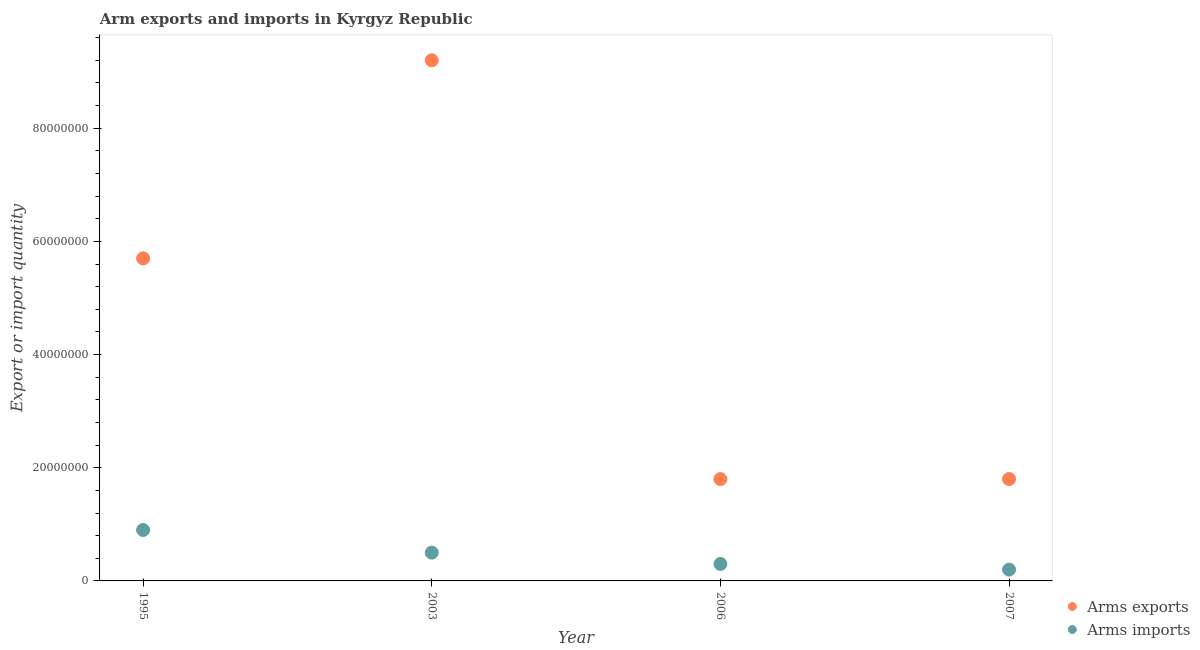How many different coloured dotlines are there?
Your answer should be very brief. 2. What is the arms imports in 2003?
Your answer should be very brief. 5.00e+06. Across all years, what is the maximum arms exports?
Give a very brief answer. 9.20e+07. Across all years, what is the minimum arms exports?
Keep it short and to the point. 1.80e+07. In which year was the arms imports maximum?
Give a very brief answer. 1995. In which year was the arms imports minimum?
Give a very brief answer. 2007. What is the total arms exports in the graph?
Give a very brief answer. 1.85e+08. What is the difference between the arms imports in 1995 and that in 2006?
Provide a short and direct response. 6.00e+06. What is the difference between the arms exports in 2003 and the arms imports in 2007?
Keep it short and to the point. 9.00e+07. What is the average arms exports per year?
Provide a short and direct response. 4.62e+07. In the year 2006, what is the difference between the arms imports and arms exports?
Your response must be concise. -1.50e+07. What is the ratio of the arms exports in 2003 to that in 2007?
Ensure brevity in your answer.  5.11. Is the difference between the arms imports in 2003 and 2006 greater than the difference between the arms exports in 2003 and 2006?
Your answer should be very brief. No. What is the difference between the highest and the second highest arms exports?
Your answer should be very brief. 3.50e+07. What is the difference between the highest and the lowest arms imports?
Provide a short and direct response. 7.00e+06. Does the arms imports monotonically increase over the years?
Provide a succinct answer. No. Is the arms imports strictly greater than the arms exports over the years?
Provide a short and direct response. No. Is the arms exports strictly less than the arms imports over the years?
Provide a succinct answer. No. How many years are there in the graph?
Your response must be concise. 4. Are the values on the major ticks of Y-axis written in scientific E-notation?
Your answer should be compact. No. Does the graph contain any zero values?
Your answer should be very brief. No. Where does the legend appear in the graph?
Give a very brief answer. Bottom right. What is the title of the graph?
Your response must be concise. Arm exports and imports in Kyrgyz Republic. Does "Number of arrivals" appear as one of the legend labels in the graph?
Give a very brief answer. No. What is the label or title of the Y-axis?
Offer a very short reply. Export or import quantity. What is the Export or import quantity in Arms exports in 1995?
Provide a short and direct response. 5.70e+07. What is the Export or import quantity of Arms imports in 1995?
Make the answer very short. 9.00e+06. What is the Export or import quantity in Arms exports in 2003?
Your response must be concise. 9.20e+07. What is the Export or import quantity in Arms exports in 2006?
Provide a short and direct response. 1.80e+07. What is the Export or import quantity in Arms imports in 2006?
Offer a very short reply. 3.00e+06. What is the Export or import quantity of Arms exports in 2007?
Ensure brevity in your answer.  1.80e+07. What is the Export or import quantity of Arms imports in 2007?
Offer a very short reply. 2.00e+06. Across all years, what is the maximum Export or import quantity in Arms exports?
Provide a short and direct response. 9.20e+07. Across all years, what is the maximum Export or import quantity in Arms imports?
Offer a terse response. 9.00e+06. Across all years, what is the minimum Export or import quantity of Arms exports?
Make the answer very short. 1.80e+07. Across all years, what is the minimum Export or import quantity in Arms imports?
Your answer should be compact. 2.00e+06. What is the total Export or import quantity in Arms exports in the graph?
Offer a terse response. 1.85e+08. What is the total Export or import quantity of Arms imports in the graph?
Your response must be concise. 1.90e+07. What is the difference between the Export or import quantity in Arms exports in 1995 and that in 2003?
Keep it short and to the point. -3.50e+07. What is the difference between the Export or import quantity of Arms imports in 1995 and that in 2003?
Keep it short and to the point. 4.00e+06. What is the difference between the Export or import quantity in Arms exports in 1995 and that in 2006?
Make the answer very short. 3.90e+07. What is the difference between the Export or import quantity of Arms exports in 1995 and that in 2007?
Your answer should be very brief. 3.90e+07. What is the difference between the Export or import quantity of Arms imports in 1995 and that in 2007?
Your answer should be compact. 7.00e+06. What is the difference between the Export or import quantity in Arms exports in 2003 and that in 2006?
Ensure brevity in your answer.  7.40e+07. What is the difference between the Export or import quantity in Arms exports in 2003 and that in 2007?
Keep it short and to the point. 7.40e+07. What is the difference between the Export or import quantity in Arms imports in 2003 and that in 2007?
Your response must be concise. 3.00e+06. What is the difference between the Export or import quantity in Arms imports in 2006 and that in 2007?
Your answer should be compact. 1.00e+06. What is the difference between the Export or import quantity in Arms exports in 1995 and the Export or import quantity in Arms imports in 2003?
Give a very brief answer. 5.20e+07. What is the difference between the Export or import quantity of Arms exports in 1995 and the Export or import quantity of Arms imports in 2006?
Provide a short and direct response. 5.40e+07. What is the difference between the Export or import quantity in Arms exports in 1995 and the Export or import quantity in Arms imports in 2007?
Give a very brief answer. 5.50e+07. What is the difference between the Export or import quantity in Arms exports in 2003 and the Export or import quantity in Arms imports in 2006?
Make the answer very short. 8.90e+07. What is the difference between the Export or import quantity of Arms exports in 2003 and the Export or import quantity of Arms imports in 2007?
Provide a short and direct response. 9.00e+07. What is the difference between the Export or import quantity of Arms exports in 2006 and the Export or import quantity of Arms imports in 2007?
Ensure brevity in your answer.  1.60e+07. What is the average Export or import quantity in Arms exports per year?
Give a very brief answer. 4.62e+07. What is the average Export or import quantity in Arms imports per year?
Your answer should be compact. 4.75e+06. In the year 1995, what is the difference between the Export or import quantity of Arms exports and Export or import quantity of Arms imports?
Your answer should be compact. 4.80e+07. In the year 2003, what is the difference between the Export or import quantity in Arms exports and Export or import quantity in Arms imports?
Your response must be concise. 8.70e+07. In the year 2006, what is the difference between the Export or import quantity of Arms exports and Export or import quantity of Arms imports?
Provide a succinct answer. 1.50e+07. In the year 2007, what is the difference between the Export or import quantity in Arms exports and Export or import quantity in Arms imports?
Your answer should be very brief. 1.60e+07. What is the ratio of the Export or import quantity in Arms exports in 1995 to that in 2003?
Your response must be concise. 0.62. What is the ratio of the Export or import quantity in Arms exports in 1995 to that in 2006?
Offer a terse response. 3.17. What is the ratio of the Export or import quantity in Arms imports in 1995 to that in 2006?
Your response must be concise. 3. What is the ratio of the Export or import quantity in Arms exports in 1995 to that in 2007?
Offer a very short reply. 3.17. What is the ratio of the Export or import quantity in Arms exports in 2003 to that in 2006?
Provide a short and direct response. 5.11. What is the ratio of the Export or import quantity in Arms exports in 2003 to that in 2007?
Provide a succinct answer. 5.11. What is the ratio of the Export or import quantity in Arms exports in 2006 to that in 2007?
Offer a very short reply. 1. What is the ratio of the Export or import quantity of Arms imports in 2006 to that in 2007?
Make the answer very short. 1.5. What is the difference between the highest and the second highest Export or import quantity of Arms exports?
Offer a very short reply. 3.50e+07. What is the difference between the highest and the second highest Export or import quantity of Arms imports?
Your response must be concise. 4.00e+06. What is the difference between the highest and the lowest Export or import quantity in Arms exports?
Offer a very short reply. 7.40e+07. 